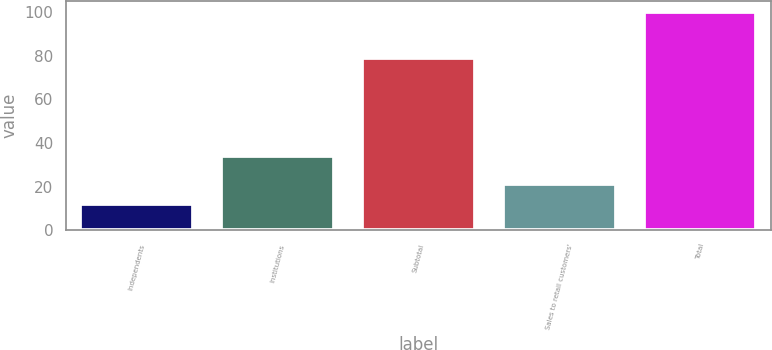Convert chart to OTSL. <chart><loc_0><loc_0><loc_500><loc_500><bar_chart><fcel>Independents<fcel>Institutions<fcel>Subtotal<fcel>Sales to retail customers'<fcel>Total<nl><fcel>12<fcel>34<fcel>79<fcel>21<fcel>100<nl></chart> 